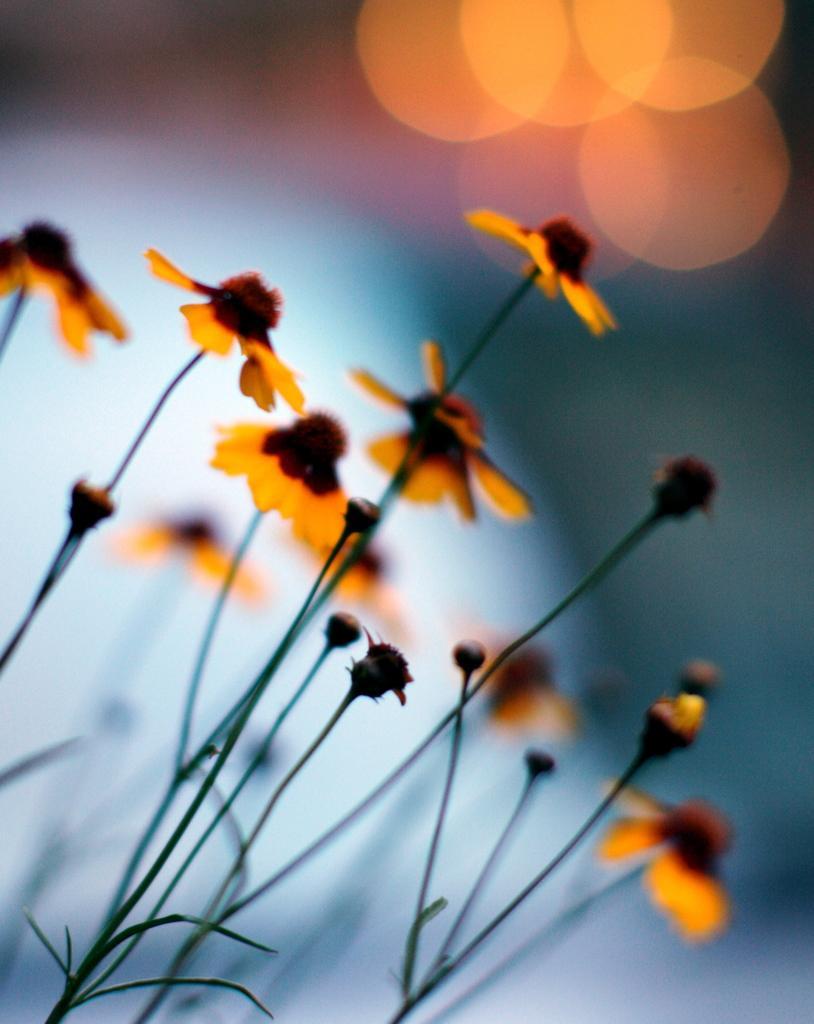Could you give a brief overview of what you see in this image? In this picture we can see the orange color small flowers plant. Behind there is a blur background. 